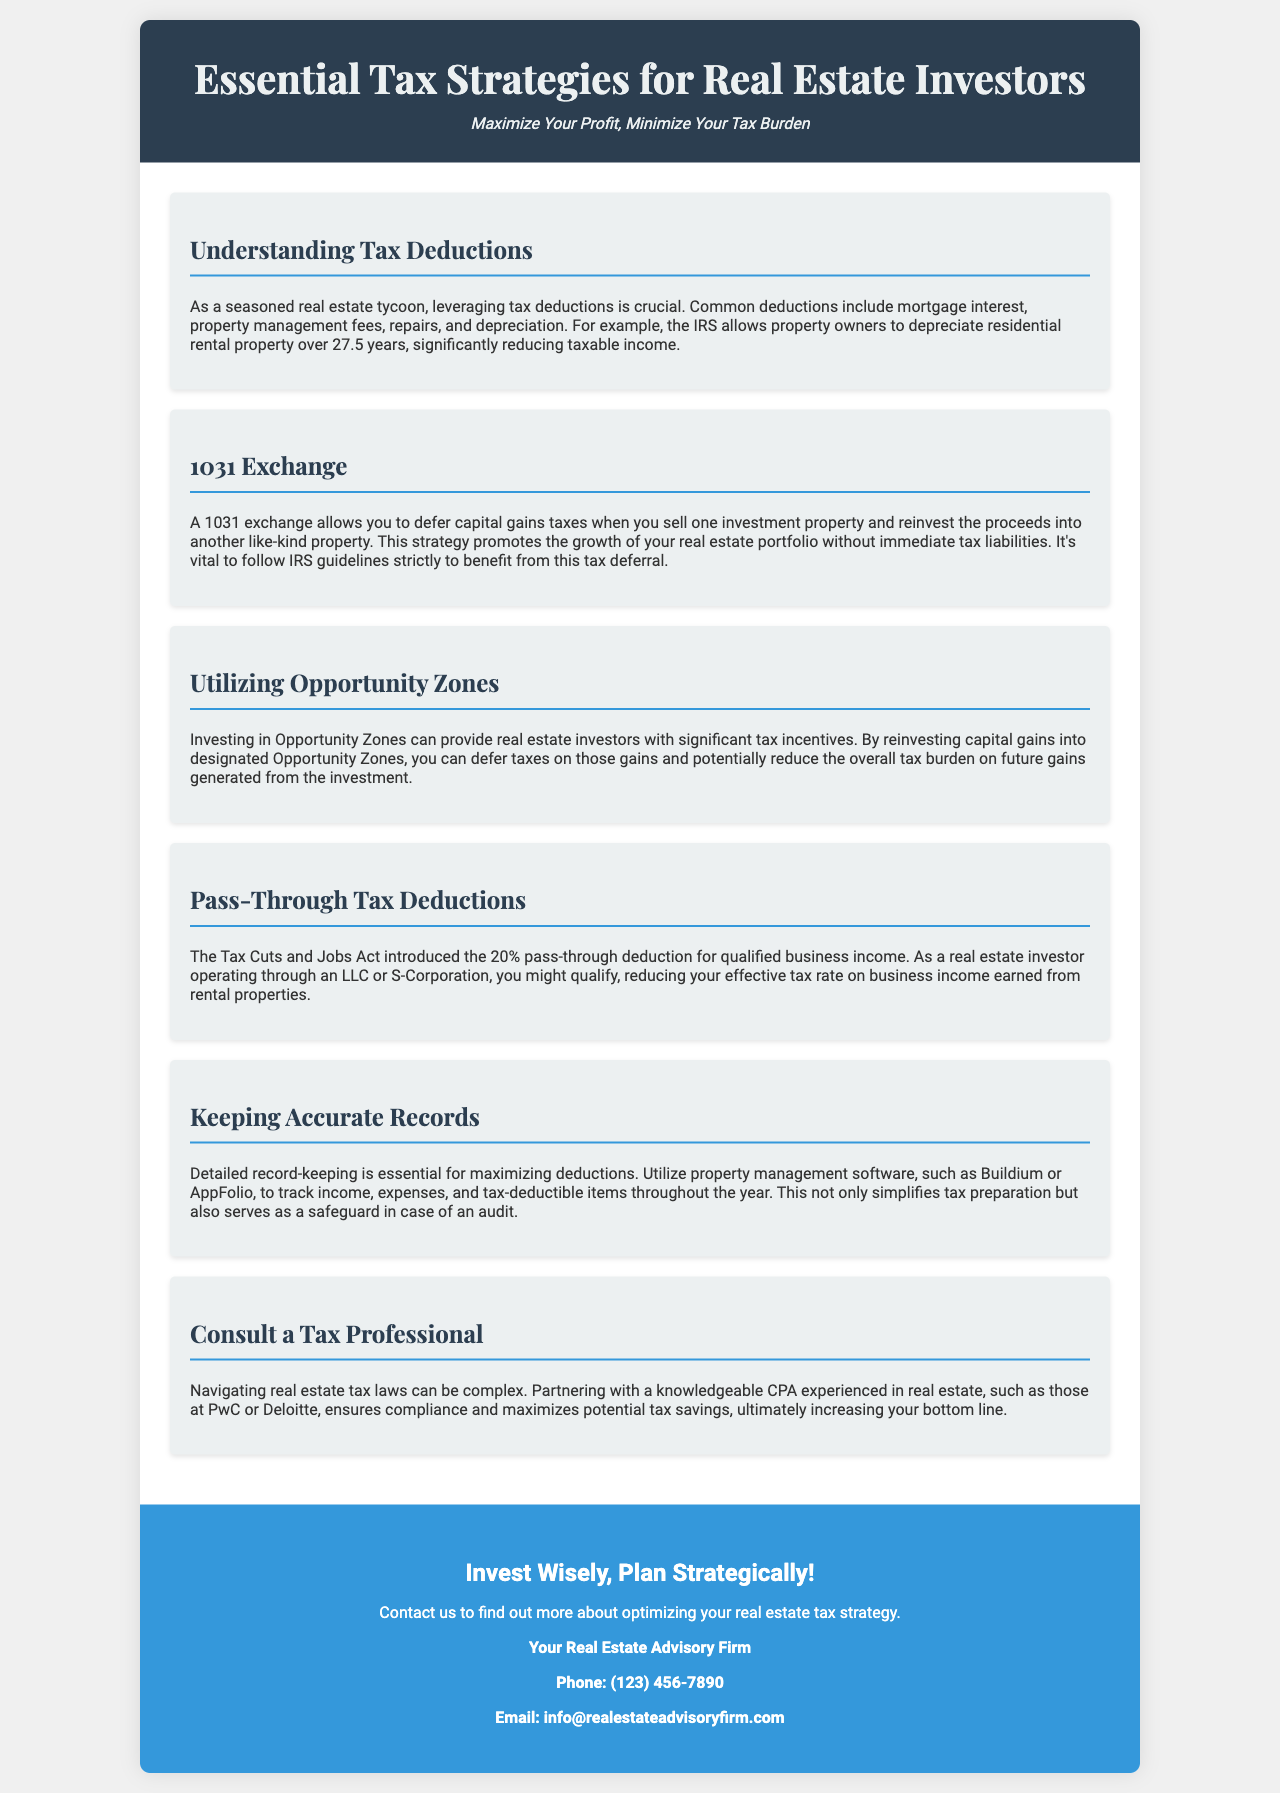What are common tax deductions for real estate investors? The document lists mortgage interest, property management fees, repairs, and depreciation as common deductions.
Answer: mortgage interest, property management fees, repairs, depreciation What is the duration for depreciating residential rental property? The document states that residential rental property can be depreciated over 27.5 years.
Answer: 27.5 years What is a 1031 exchange? A 1031 exchange allows you to defer capital gains taxes when selling and reinvesting in a like-kind property.
Answer: Defer capital gains taxes What is the pass-through deduction percentage introduced by the Tax Cuts and Jobs Act? The document mentions the pass-through deduction is 20%.
Answer: 20% What software is recommended for record-keeping? The brochure suggests using property management software like Buildium or AppFolio for tracking.
Answer: Buildium, AppFolio What is advised to ensure tax compliance and savings? The document advises partnering with a knowledgeable CPA experienced in real estate for tax compliance and savings.
Answer: Consult a tax professional How can investing in Opportunity Zones benefit investors? By reinvesting capital gains into Opportunity Zones, investors can defer taxes and reduce the overall tax burden on future gains.
Answer: Tax deferment and reduced burden What does the brochure encourage at the end? The brochure encourages investing wisely and planning strategically in real estate.
Answer: Invest wisely, plan strategically What type of professional is recommended for tax navigation? The document recommends working with a knowledgeable CPA experienced in real estate.
Answer: CPA 